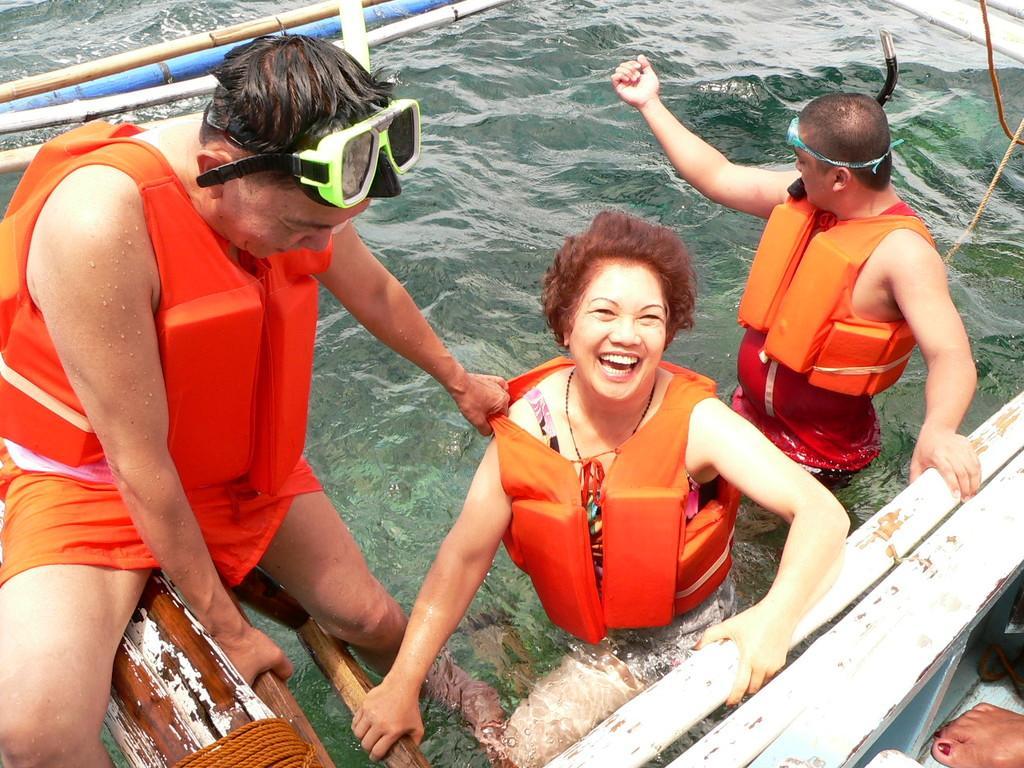In one or two sentences, can you explain what this image depicts? In this picture, we see three people are in the water. The man on the left side is sitting on the wooden stick. Beside him, we see a wooden ladder. The woman in the middle is smiling. Beside her, we see an iron rod. In the background, we see the rods in white and blue color. 